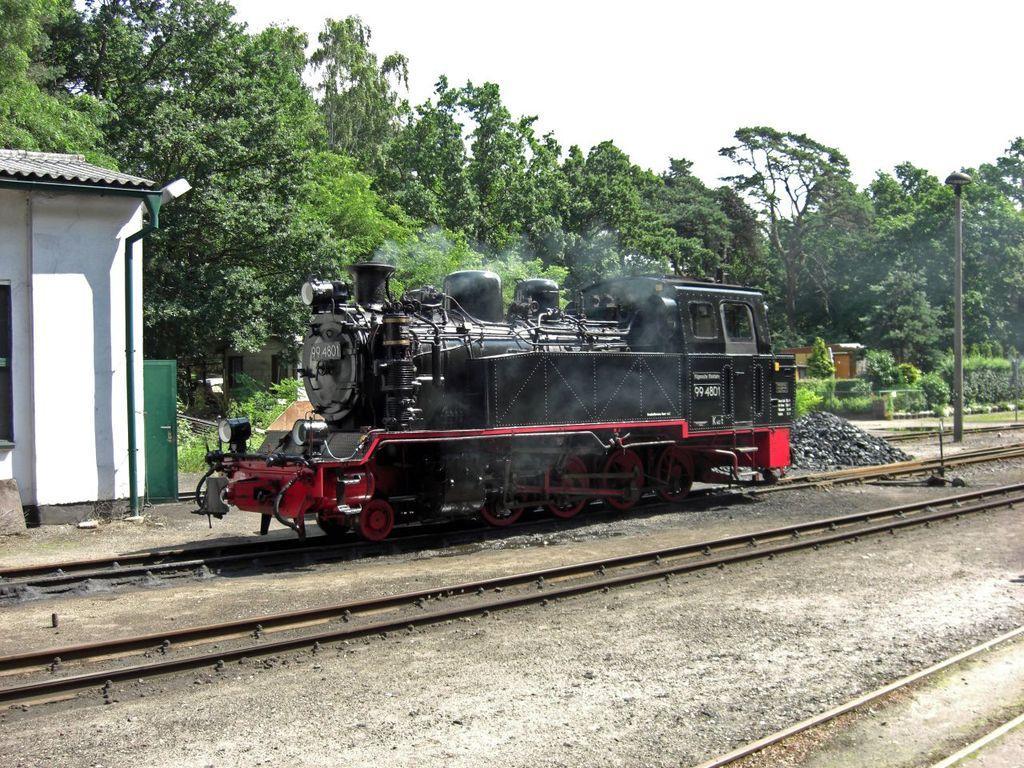Can you describe this image briefly? This picture is clicked outside. In the center there is a train running on the railway track and we can see the railway tracks and we can see the shed, trees plants, grass, stones, light attached to the pole. In the background we can see the sky and some other objects. 